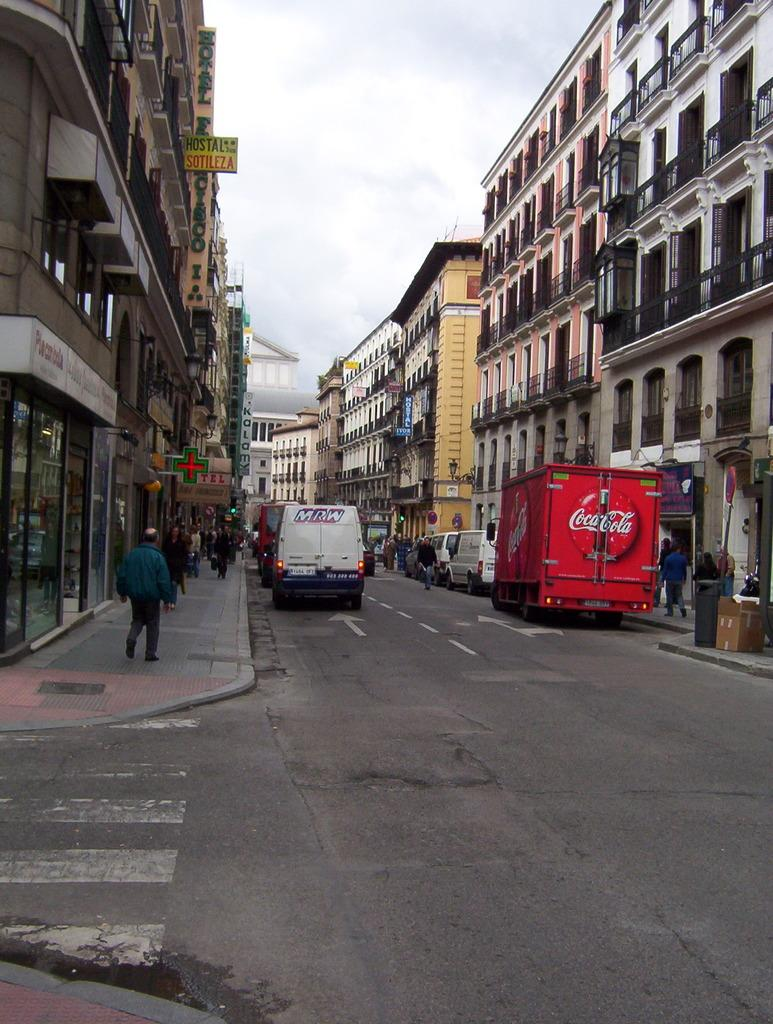What can be seen on the road in the image? There are vehicles on the road in the image. What are the people in the image doing? There are groups of people walking in the image. What can be seen on the buildings in the image? There are buildings with name boards in the image. What is visible in the background of the image? The sky is visible in the background of the image. What type of apparatus is being used by the family in the image? There is no family or apparatus present in the image. How does the growth of the plants affect the image? There are no plants visible in the image, so their growth cannot be assessed. 